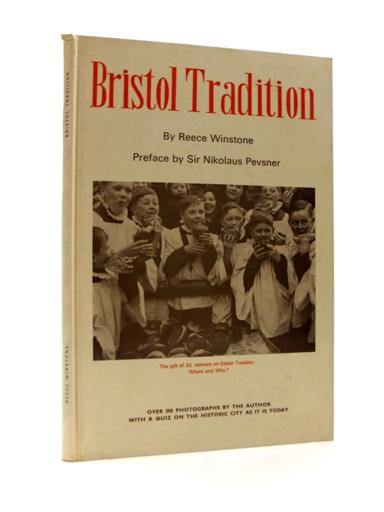Who wrote the preface for the book? The preface of the book "Bristol Tradition" was penned by Sir Nikolaus Pevsner, a notable figure known for his expertise in the history and architecture of British buildings, adding significant scholarly value to the book. 